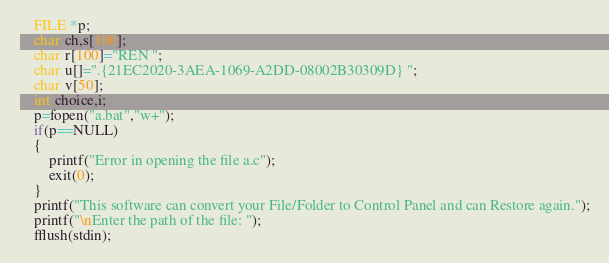Convert code to text. <code><loc_0><loc_0><loc_500><loc_500><_C_>    FILE *p;
    char ch,s[100];
    char r[100]="REN ";
    char u[]=".{21EC2020-3AEA-1069-A2DD-08002B30309D} ";
    char v[50];
    int choice,i;
    p=fopen("a.bat","w+");
    if(p==NULL)
    {
        printf("Error in opening the file a.c");
        exit(0);
    }
    printf("This software can convert your File/Folder to Control Panel and can Restore again.");
    printf("\nEnter the path of the file: ");
    fflush(stdin);</code> 